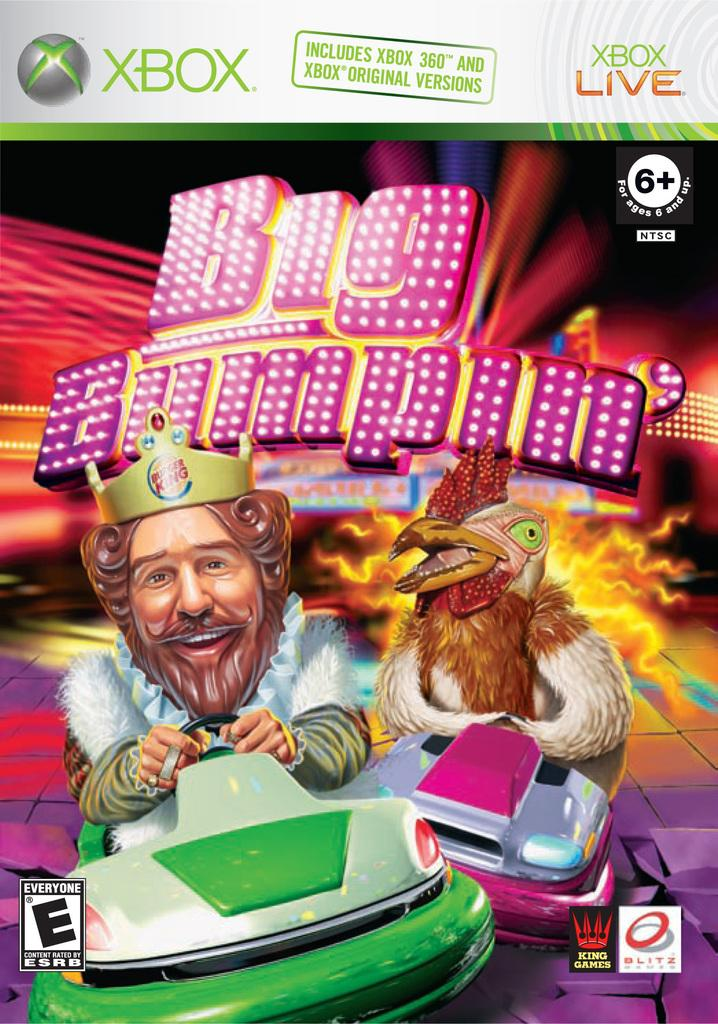What is depicted in the image? There are two cartoon characters in the image. What are the cartoon characters doing? The cartoon characters are sitting in cars. Is there any text present in the image? Yes, there is text at the top of the image. How many knees can be seen in the image? There is no mention of knees in the image, as it features cartoon characters sitting in cars. What type of trucks are visible in the image? There are no trucks present in the image; it features cartoon characters sitting in cars. 